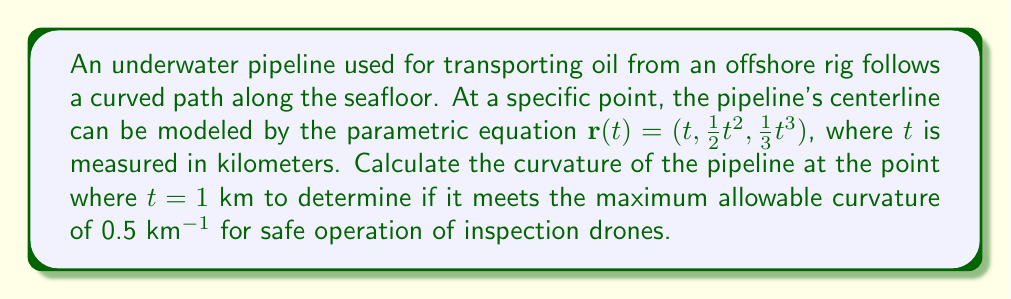What is the answer to this math problem? To calculate the curvature of the pipeline, we'll use the formula for the curvature of a space curve:

$$\kappa = \frac{\|\mathbf{r}'(t) \times \mathbf{r}''(t)\|}{\|\mathbf{r}'(t)\|^3}$$

Step 1: Calculate $\mathbf{r}'(t)$ and $\mathbf{r}''(t)$
$\mathbf{r}'(t) = (1, t, t^2)$
$\mathbf{r}''(t) = (0, 1, 2t)$

Step 2: Evaluate $\mathbf{r}'(t)$ and $\mathbf{r}''(t)$ at $t = 1$
$\mathbf{r}'(1) = (1, 1, 1)$
$\mathbf{r}''(1) = (0, 1, 2)$

Step 3: Calculate $\mathbf{r}'(1) \times \mathbf{r}''(1)$
$$\mathbf{r}'(1) \times \mathbf{r}''(1) = \begin{vmatrix} 
\mathbf{i} & \mathbf{j} & \mathbf{k} \\
1 & 1 & 1 \\
0 & 1 & 2
\end{vmatrix} = (1)\mathbf{i} + (-2)\mathbf{j} + (1)\mathbf{k} = (1, -2, 1)$$

Step 4: Calculate $\|\mathbf{r}'(1) \times \mathbf{r}''(1)\|$
$$\|\mathbf{r}'(1) \times \mathbf{r}''(1)\| = \sqrt{1^2 + (-2)^2 + 1^2} = \sqrt{6}$$

Step 5: Calculate $\|\mathbf{r}'(1)\|^3$
$$\|\mathbf{r}'(1)\|^3 = ({\sqrt{1^2 + 1^2 + 1^2}})^3 = {\sqrt{3}}^3 = 3\sqrt{3}$$

Step 6: Apply the curvature formula
$$\kappa = \frac{\|\mathbf{r}'(1) \times \mathbf{r}''(1)\|}{\|\mathbf{r}'(1)\|^3} = \frac{\sqrt{6}}{3\sqrt{3}} = \frac{\sqrt{2}}{3}$$

Step 7: Compare with the maximum allowable curvature
$\frac{\sqrt{2}}{3} \approx 0.4714 < 0.5$ km^(-1)
Answer: $\kappa = \frac{\sqrt{2}}{3}$ km^(-1) 